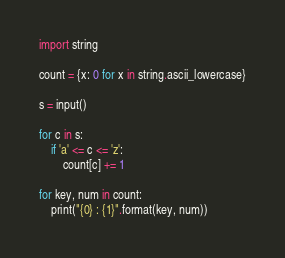<code> <loc_0><loc_0><loc_500><loc_500><_Python_>import string

count = {x: 0 for x in string.ascii_lowercase}

s = input()

for c in s:
    if 'a' <= c <= 'z':
        count[c] += 1
        
for key, num in count:
    print("{0} : {1}".format(key, num))</code> 